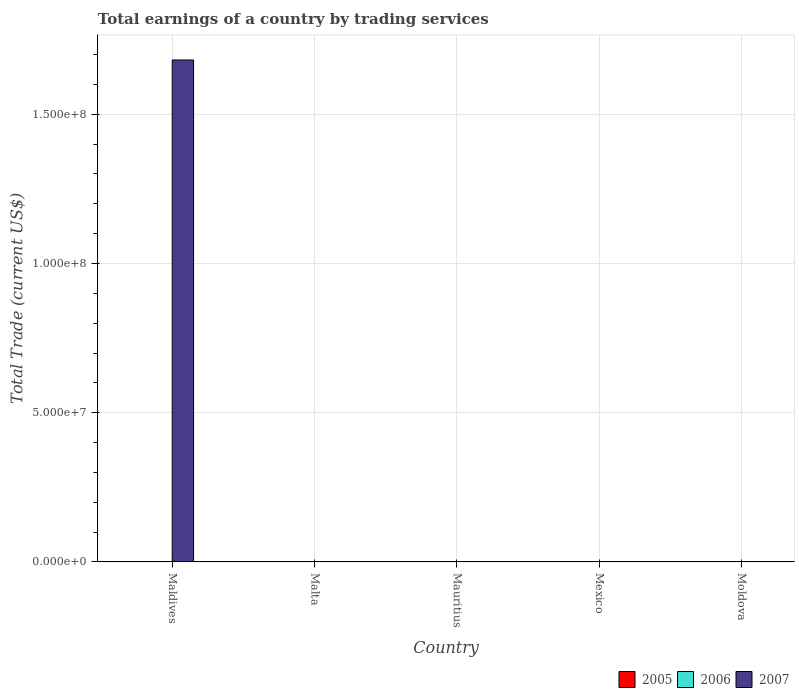How many different coloured bars are there?
Provide a short and direct response. 1. Are the number of bars per tick equal to the number of legend labels?
Provide a succinct answer. No. How many bars are there on the 1st tick from the left?
Offer a very short reply. 1. How many bars are there on the 4th tick from the right?
Keep it short and to the point. 0. What is the label of the 4th group of bars from the left?
Your answer should be very brief. Mexico. In how many cases, is the number of bars for a given country not equal to the number of legend labels?
Your answer should be very brief. 5. Across all countries, what is the maximum total earnings in 2007?
Keep it short and to the point. 1.68e+08. Across all countries, what is the minimum total earnings in 2007?
Offer a terse response. 0. In which country was the total earnings in 2007 maximum?
Ensure brevity in your answer.  Maldives. What is the total total earnings in 2007 in the graph?
Your answer should be very brief. 1.68e+08. What is the difference between the total earnings in 2006 in Moldova and the total earnings in 2005 in Malta?
Your answer should be compact. 0. What is the average total earnings in 2005 per country?
Keep it short and to the point. 0. In how many countries, is the total earnings in 2007 greater than 20000000 US$?
Offer a terse response. 1. What is the difference between the highest and the lowest total earnings in 2007?
Offer a very short reply. 1.68e+08. In how many countries, is the total earnings in 2005 greater than the average total earnings in 2005 taken over all countries?
Ensure brevity in your answer.  0. Is it the case that in every country, the sum of the total earnings in 2007 and total earnings in 2005 is greater than the total earnings in 2006?
Your answer should be very brief. No. Are all the bars in the graph horizontal?
Make the answer very short. No. How many countries are there in the graph?
Provide a succinct answer. 5. Are the values on the major ticks of Y-axis written in scientific E-notation?
Offer a terse response. Yes. Where does the legend appear in the graph?
Your answer should be very brief. Bottom right. How are the legend labels stacked?
Offer a very short reply. Horizontal. What is the title of the graph?
Ensure brevity in your answer.  Total earnings of a country by trading services. What is the label or title of the X-axis?
Your response must be concise. Country. What is the label or title of the Y-axis?
Make the answer very short. Total Trade (current US$). What is the Total Trade (current US$) of 2005 in Maldives?
Give a very brief answer. 0. What is the Total Trade (current US$) in 2006 in Maldives?
Make the answer very short. 0. What is the Total Trade (current US$) of 2007 in Maldives?
Provide a short and direct response. 1.68e+08. What is the Total Trade (current US$) of 2007 in Malta?
Your answer should be compact. 0. What is the Total Trade (current US$) in 2005 in Mauritius?
Offer a very short reply. 0. What is the Total Trade (current US$) in 2007 in Mauritius?
Keep it short and to the point. 0. What is the Total Trade (current US$) of 2007 in Mexico?
Keep it short and to the point. 0. What is the Total Trade (current US$) in 2005 in Moldova?
Your answer should be compact. 0. What is the Total Trade (current US$) of 2007 in Moldova?
Give a very brief answer. 0. Across all countries, what is the maximum Total Trade (current US$) in 2007?
Keep it short and to the point. 1.68e+08. Across all countries, what is the minimum Total Trade (current US$) of 2007?
Your response must be concise. 0. What is the total Total Trade (current US$) in 2005 in the graph?
Offer a terse response. 0. What is the total Total Trade (current US$) of 2006 in the graph?
Your response must be concise. 0. What is the total Total Trade (current US$) of 2007 in the graph?
Provide a succinct answer. 1.68e+08. What is the average Total Trade (current US$) in 2007 per country?
Offer a very short reply. 3.36e+07. What is the difference between the highest and the lowest Total Trade (current US$) in 2007?
Provide a succinct answer. 1.68e+08. 